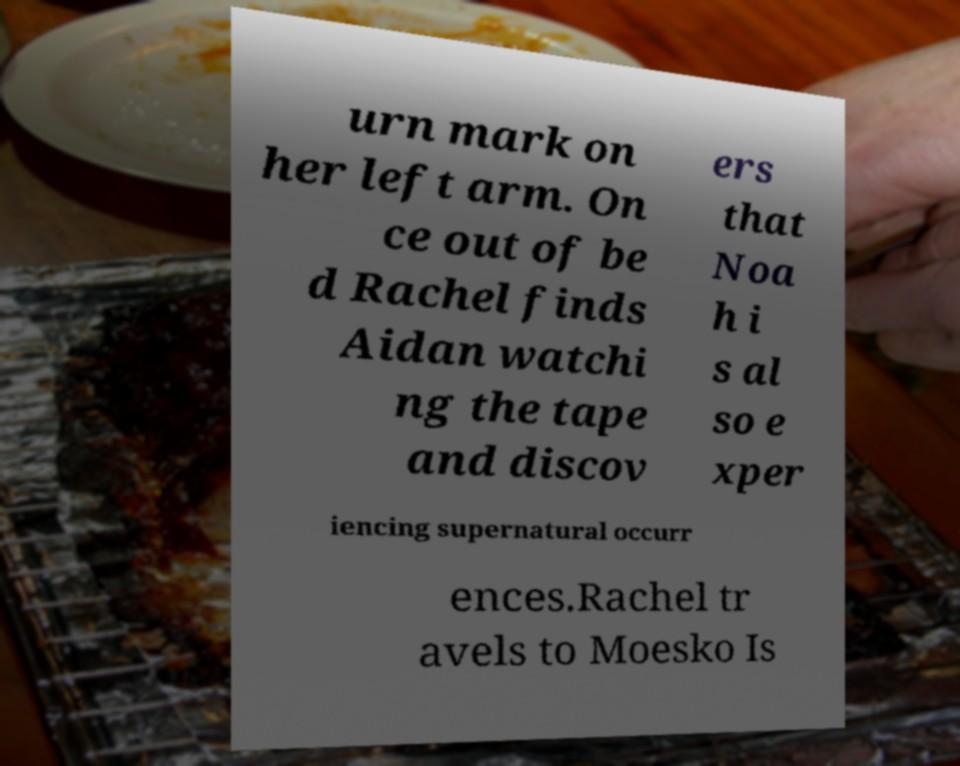Please identify and transcribe the text found in this image. urn mark on her left arm. On ce out of be d Rachel finds Aidan watchi ng the tape and discov ers that Noa h i s al so e xper iencing supernatural occurr ences.Rachel tr avels to Moesko Is 